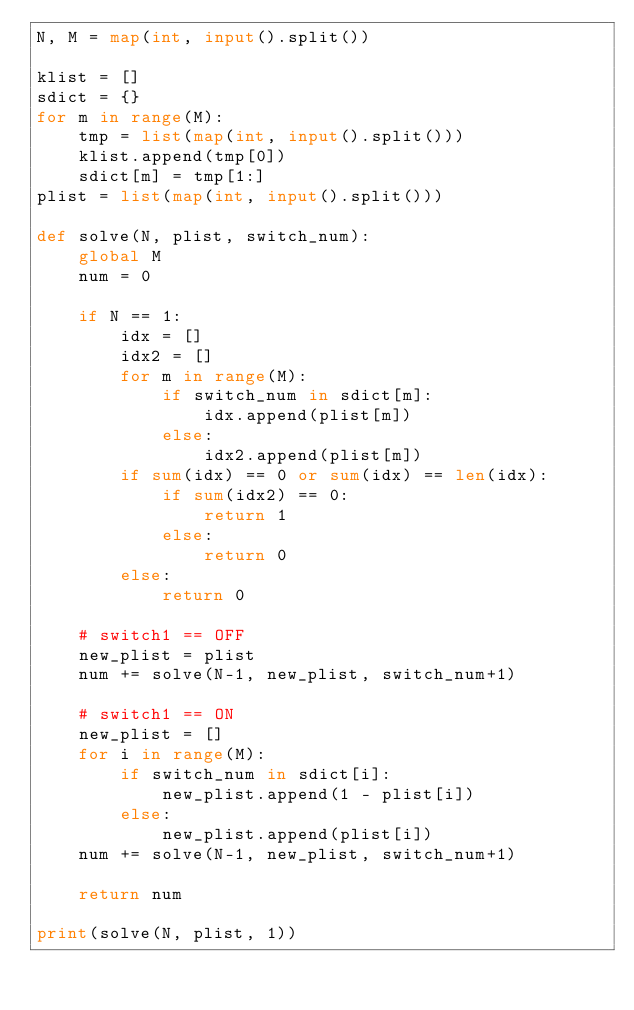Convert code to text. <code><loc_0><loc_0><loc_500><loc_500><_Python_>N, M = map(int, input().split())

klist = []
sdict = {}
for m in range(M):
    tmp = list(map(int, input().split()))
    klist.append(tmp[0])
    sdict[m] = tmp[1:]
plist = list(map(int, input().split()))

def solve(N, plist, switch_num):
    global M
    num = 0

    if N == 1:
        idx = []
        idx2 = []
        for m in range(M):
            if switch_num in sdict[m]:
                idx.append(plist[m])
            else:
                idx2.append(plist[m])
        if sum(idx) == 0 or sum(idx) == len(idx):
            if sum(idx2) == 0:
                return 1
            else:
                return 0
        else:
            return 0

    # switch1 == OFF
    new_plist = plist
    num += solve(N-1, new_plist, switch_num+1)
    
    # switch1 == ON
    new_plist = []
    for i in range(M):
        if switch_num in sdict[i]:
            new_plist.append(1 - plist[i])
        else:
            new_plist.append(plist[i])
    num += solve(N-1, new_plist, switch_num+1)

    return num

print(solve(N, plist, 1))
</code> 